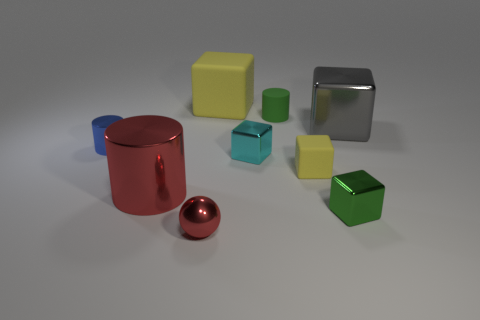Subtract all green metal cubes. How many cubes are left? 4 Subtract 2 cubes. How many cubes are left? 3 Subtract all green blocks. How many blocks are left? 4 Subtract all purple cubes. Subtract all purple balls. How many cubes are left? 5 Add 1 big gray balls. How many objects exist? 10 Subtract all spheres. How many objects are left? 8 Subtract 1 gray blocks. How many objects are left? 8 Subtract all tiny blue objects. Subtract all big red objects. How many objects are left? 7 Add 5 tiny metal spheres. How many tiny metal spheres are left? 6 Add 4 yellow matte blocks. How many yellow matte blocks exist? 6 